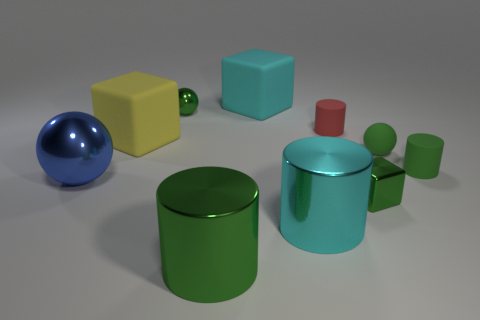Are the shadows in the image consistent with a single light source? The shadows and highlights in the image suggest that there is a single light source. Each object casts a shadow opposite to where the light appears to originate, and the highlights on each object indicate a similar angle of light incidence. 